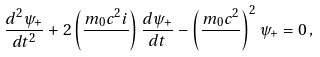Convert formula to latex. <formula><loc_0><loc_0><loc_500><loc_500>\frac { d ^ { 2 } \psi _ { + } } { d t ^ { 2 } } + 2 \left ( \frac { m _ { 0 } c ^ { 2 } i } { } \right ) \frac { d \psi _ { + } } { d t } - \left ( \frac { m _ { 0 } c ^ { 2 } } { } \right ) ^ { 2 } \psi _ { + } = 0 \, ,</formula> 